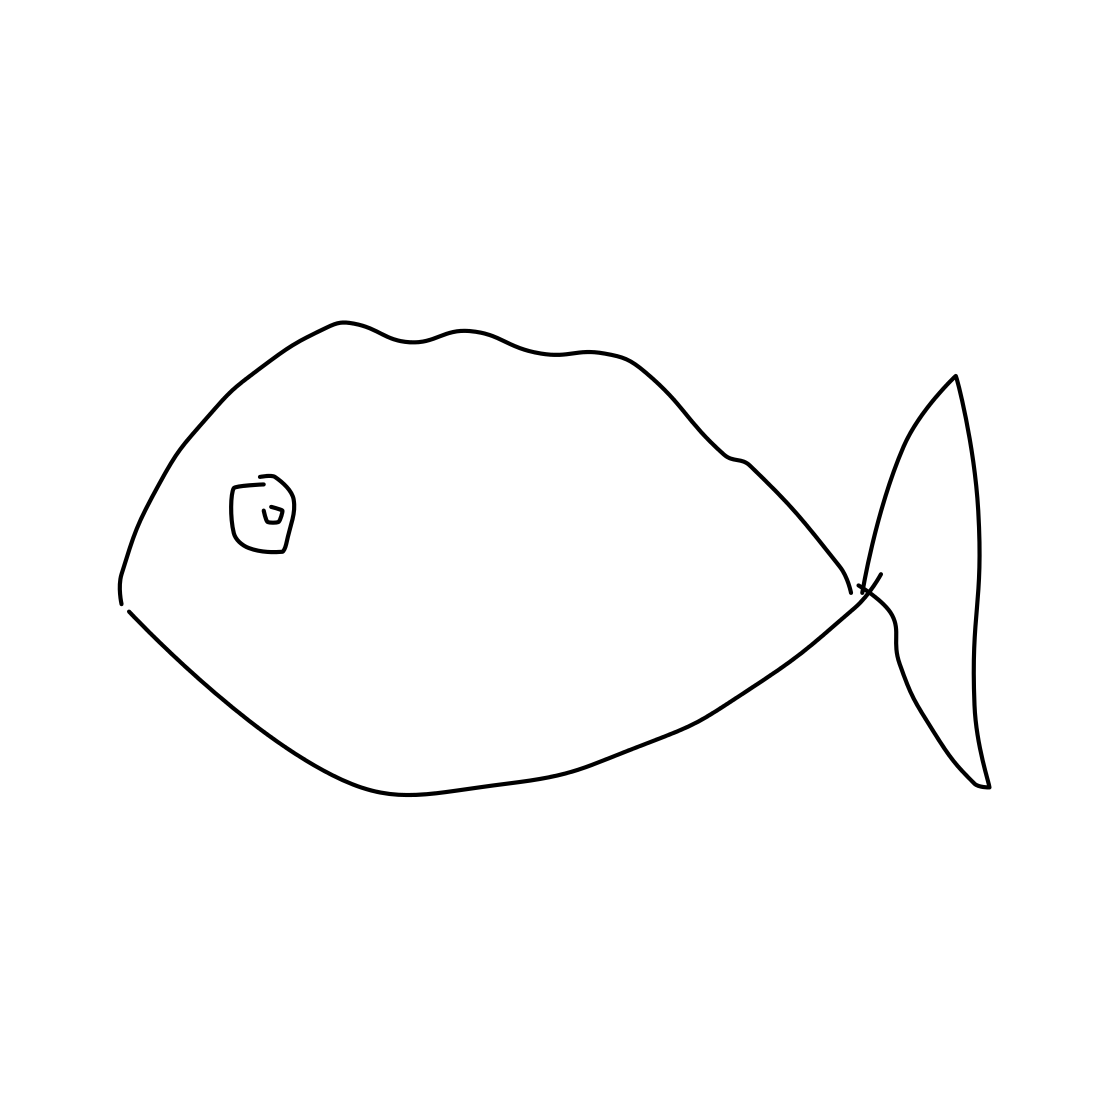Can you tell me more about the style of this drawing? Certainly! The image features a stylized drawing with clean lines and minimal detail, reminiscent of a basic sketch or a simple line art. It lacks shading and textures, which gives it an abstract and modern look, emphasizing form and outline over detail. 